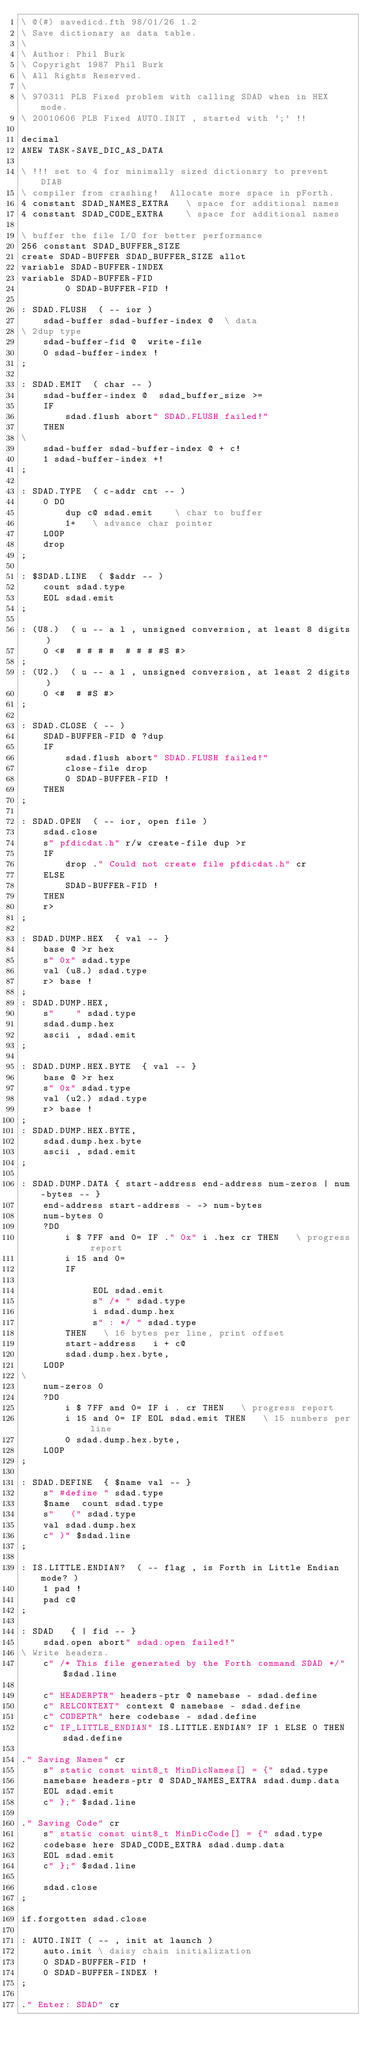<code> <loc_0><loc_0><loc_500><loc_500><_Forth_>\ @(#) savedicd.fth 98/01/26 1.2
\ Save dictionary as data table.
\
\ Author: Phil Burk
\ Copyright 1987 Phil Burk
\ All Rights Reserved.
\
\ 970311 PLB Fixed problem with calling SDAD when in HEX mode.
\ 20010606 PLB Fixed AUTO.INIT , started with ';' !!

decimal
ANEW TASK-SAVE_DIC_AS_DATA

\ !!! set to 4 for minimally sized dictionary to prevent DIAB
\ compiler from crashing!  Allocate more space in pForth.
4 constant SDAD_NAMES_EXTRA   \ space for additional names
4 constant SDAD_CODE_EXTRA    \ space for additional names

\ buffer the file I/O for better performance
256 constant SDAD_BUFFER_SIZE
create SDAD-BUFFER SDAD_BUFFER_SIZE allot
variable SDAD-BUFFER-INDEX
variable SDAD-BUFFER-FID
		0 SDAD-BUFFER-FID !

: SDAD.FLUSH  ( -- ior )
	sdad-buffer sdad-buffer-index @  \ data
\ 2dup type
	sdad-buffer-fid @  write-file
	0 sdad-buffer-index !
;

: SDAD.EMIT  ( char -- )
    sdad-buffer-index @  sdad_buffer_size >=
    IF
    	sdad.flush abort" SDAD.FLUSH failed!"
    THEN
\
    sdad-buffer sdad-buffer-index @ + c!
    1 sdad-buffer-index +!
;

: SDAD.TYPE  ( c-addr cnt -- )
	0 DO
		dup c@ sdad.emit    \ char to buffer
		1+   \ advance char pointer
	LOOP
	drop
;

: $SDAD.LINE  ( $addr -- )
	count sdad.type
	EOL sdad.emit
;

: (U8.)  ( u -- a l , unsigned conversion, at least 8 digits )
	0 <#  # # # #  # # # #S #>
;
: (U2.)  ( u -- a l , unsigned conversion, at least 2 digits )
	0 <#  # #S #>
;

: SDAD.CLOSE ( -- )
	SDAD-BUFFER-FID @ ?dup
	IF
		sdad.flush abort" SDAD.FLUSH failed!"
		close-file drop
		0 SDAD-BUFFER-FID !
	THEN
;

: SDAD.OPEN  ( -- ior, open file )
	sdad.close
	s" pfdicdat.h" r/w create-file dup >r
	IF
		drop ." Could not create file pfdicdat.h" cr
	ELSE
		SDAD-BUFFER-FID !
	THEN
	r>
;

: SDAD.DUMP.HEX  { val -- }
	base @ >r hex
	s" 0x" sdad.type
	val (u8.) sdad.type
	r> base !
;
: SDAD.DUMP.HEX, 
	s"    " sdad.type
	sdad.dump.hex
	ascii , sdad.emit
;

: SDAD.DUMP.HEX.BYTE  { val -- }
	base @ >r hex
	s" 0x" sdad.type
	val (u2.) sdad.type
	r> base !
;
: SDAD.DUMP.HEX.BYTE,
	sdad.dump.hex.byte
	ascii , sdad.emit
;

: SDAD.DUMP.DATA { start-address end-address num-zeros | num-bytes -- }
	end-address start-address - -> num-bytes
	num-bytes 0
	?DO
		i $ 7FF and 0= IF ." 0x" i .hex cr THEN   \ progress report
		i 15 and 0=
		IF
			 
			 EOL sdad.emit
			 s" /* " sdad.type
			 i sdad.dump.hex
			 s" : */ " sdad.type
		THEN   \ 16 bytes per line, print offset
		start-address   i + c@
		sdad.dump.hex.byte,
	LOOP
\
	num-zeros 0
	?DO
		i $ 7FF and 0= IF i . cr THEN   \ progress report
		i 15 and 0= IF EOL sdad.emit THEN   \ 15 numbers per line
		0 sdad.dump.hex.byte,
	LOOP
;

: SDAD.DEFINE  { $name val -- }
	s" #define " sdad.type
	$name  count sdad.type
	s"   (" sdad.type
	val sdad.dump.hex
	c" )" $sdad.line
;

: IS.LITTLE.ENDIAN?  ( -- flag , is Forth in Little Endian mode? )
	1 pad !
	pad c@
;
	
: SDAD   { | fid -- }
	sdad.open abort" sdad.open failed!"
\ Write headers.
	c" /* This file generated by the Forth command SDAD */" $sdad.line

	c" HEADERPTR" headers-ptr @ namebase - sdad.define
	c" RELCONTEXT" context @ namebase - sdad.define
	c" CODEPTR" here codebase - sdad.define
	c" IF_LITTLE_ENDIAN" IS.LITTLE.ENDIAN? IF 1 ELSE 0 THEN sdad.define
	
." Saving Names" cr
	s" static const uint8_t MinDicNames[] = {" sdad.type
	namebase headers-ptr @ SDAD_NAMES_EXTRA sdad.dump.data
	EOL sdad.emit
	c" };" $sdad.line
	
." Saving Code" cr
	s" static const uint8_t MinDicCode[] = {" sdad.type
	codebase here SDAD_CODE_EXTRA sdad.dump.data
	EOL sdad.emit
	c" };" $sdad.line

	sdad.close
;

if.forgotten sdad.close

: AUTO.INIT ( -- , init at launch )
	auto.init \ daisy chain initialization
	0 SDAD-BUFFER-FID !
	0 SDAD-BUFFER-INDEX !
;

." Enter: SDAD" cr
</code> 